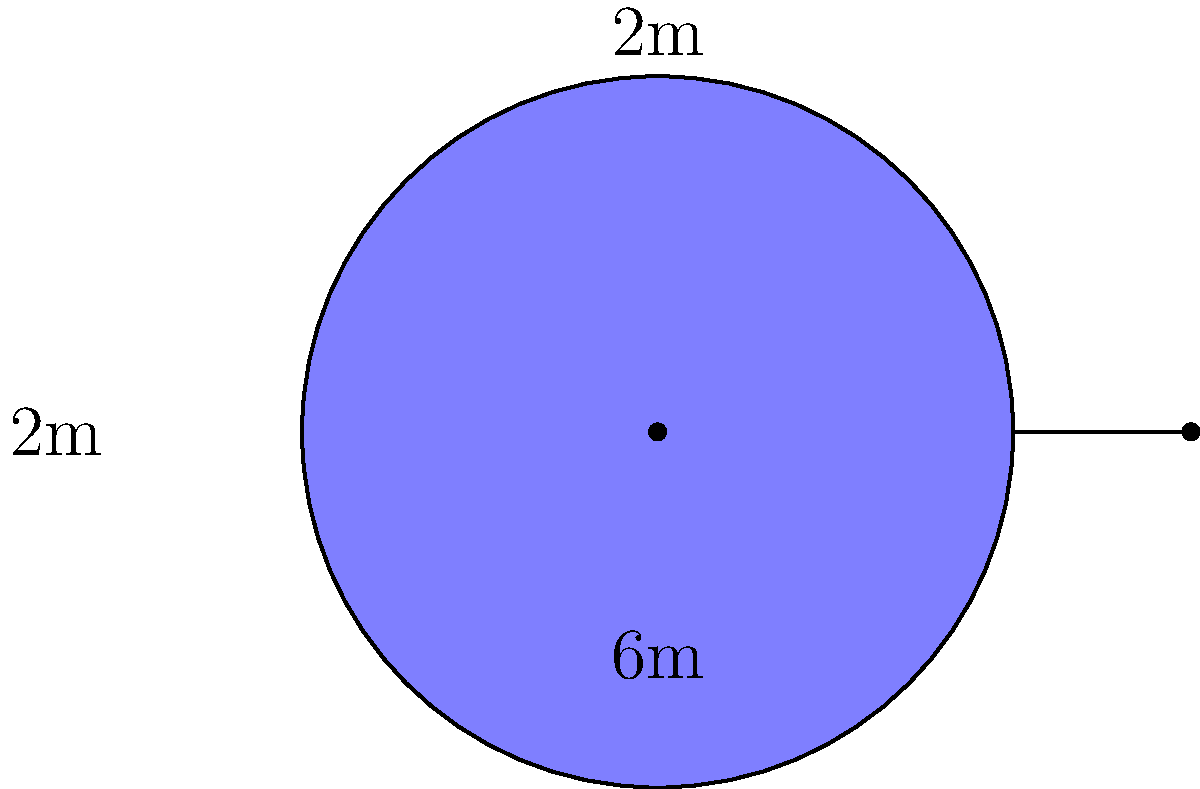A creative music teacher wants to design a unique swimming pool in the shape of a musical note for their school. The pool consists of a circular part with a radius of 2 meters and a rectangular part that is 6 meters long and 2 meters wide. Calculate the total area of this musical note-shaped pool. Let's break this down step-by-step:

1) First, we need to calculate the area of the circular part:
   Area of circle = $\pi r^2$
   $A_circle = \pi (2m)^2 = 4\pi$ m²

2) Next, we calculate the area of the rectangular part:
   Area of rectangle = length × width
   $A_rectangle = 6m \times 2m = 12$ m²

3) However, we need to subtract the area of the semicircle that overlaps with the rectangle:
   Area of semicircle = $\frac{1}{2} \pi r^2$
   $A_semicircle = \frac{1}{2} \pi (2m)^2 = 2\pi$ m²

4) Now, we can calculate the total area by adding the circle and rectangle areas, then subtracting the semicircle area:
   $A_total = A_circle + A_rectangle - A_semicircle$
   $A_total = 4\pi + 12 - 2\pi$
   $A_total = 2\pi + 12$ m²

5) We can simplify this further:
   $A_total = 2\pi + 12 \approx 18.28$ m²

This unique shape allows for creative swimming patterns, much like how we encourage students to experiment with different key combinations on a keyboard!
Answer: $2\pi + 12$ m² or approximately 18.28 m² 